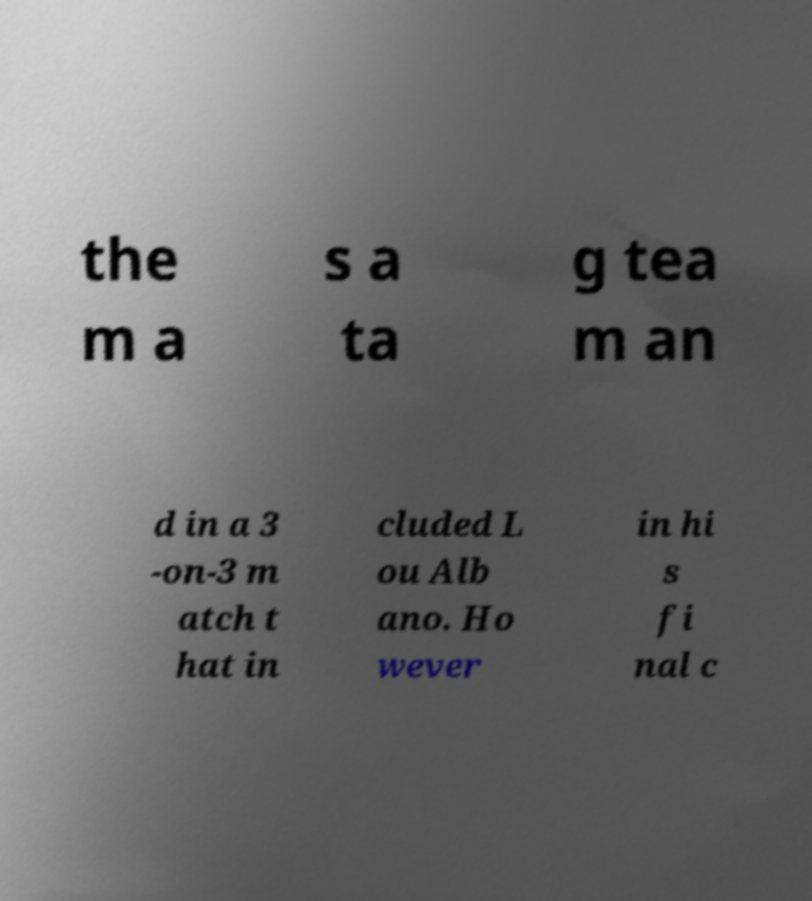Could you extract and type out the text from this image? the m a s a ta g tea m an d in a 3 -on-3 m atch t hat in cluded L ou Alb ano. Ho wever in hi s fi nal c 